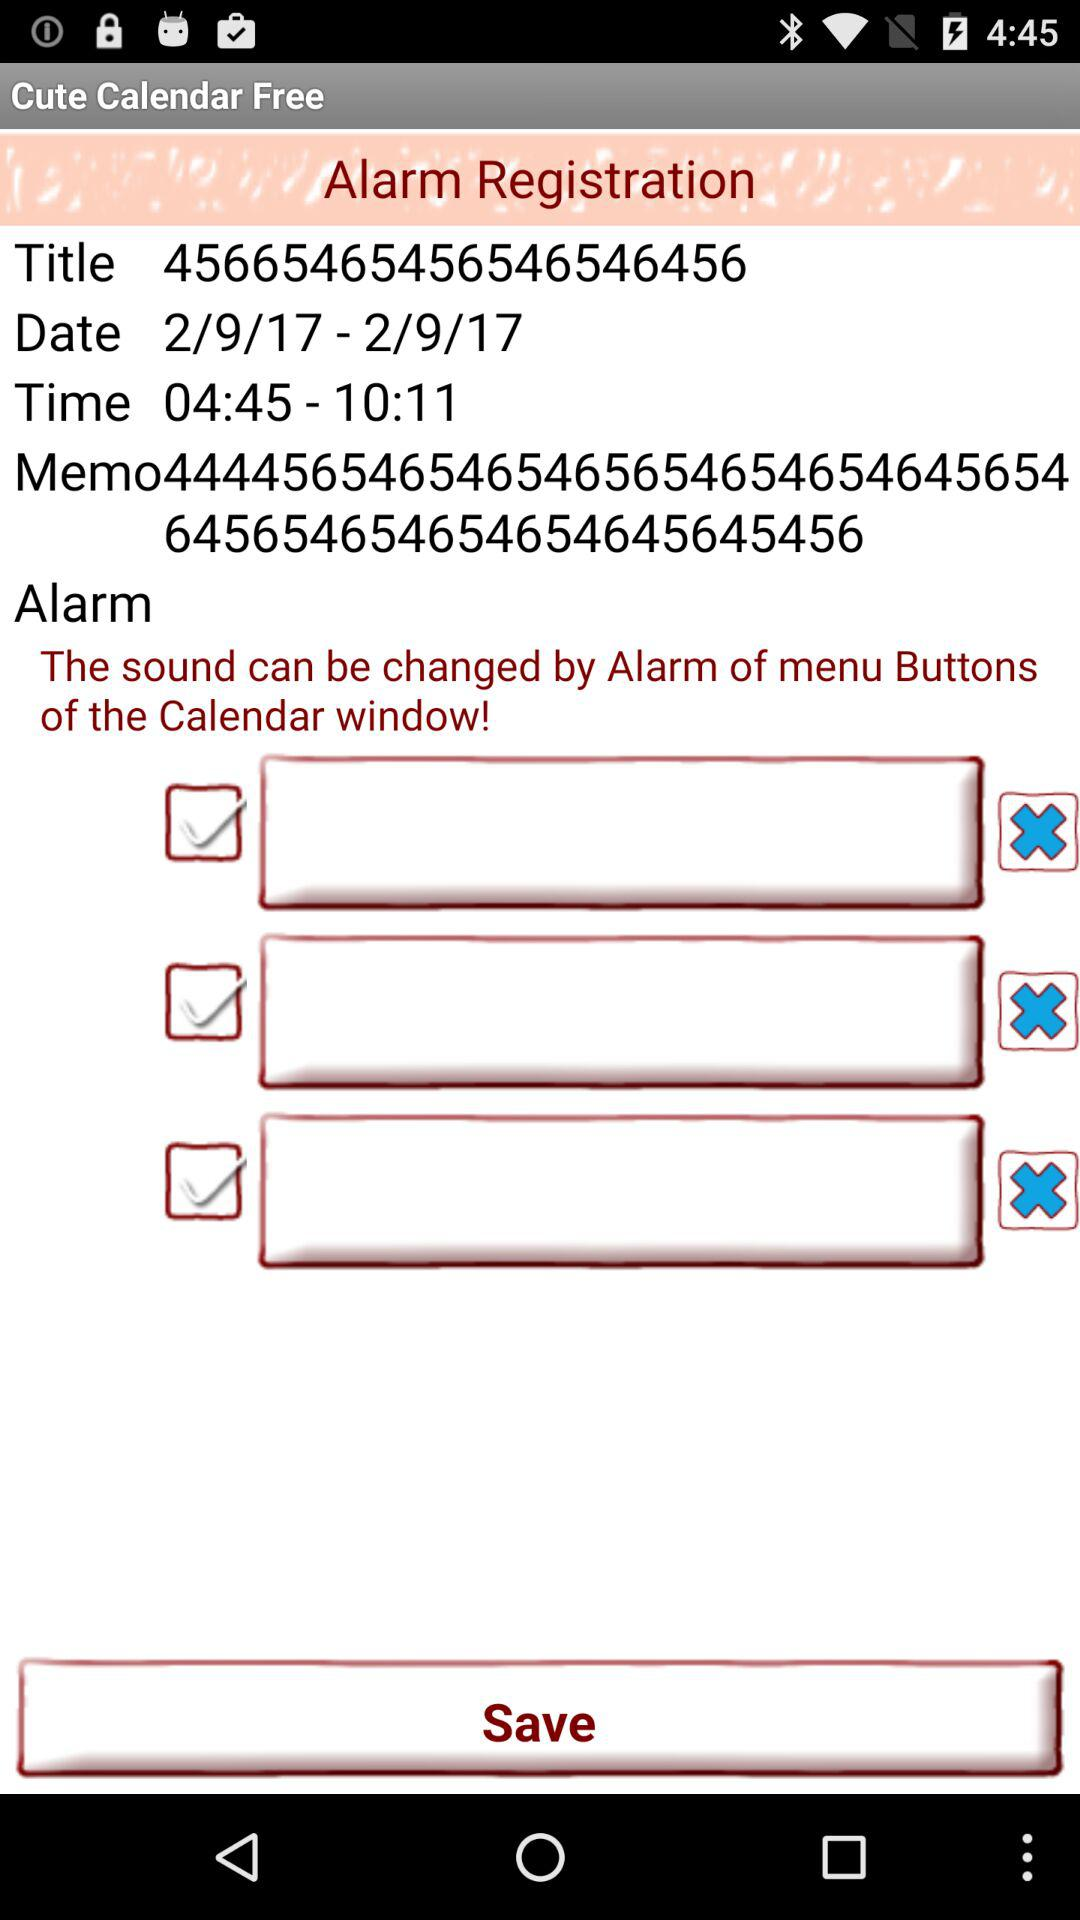What is the version number?
When the provided information is insufficient, respond with <no answer>. <no answer> 